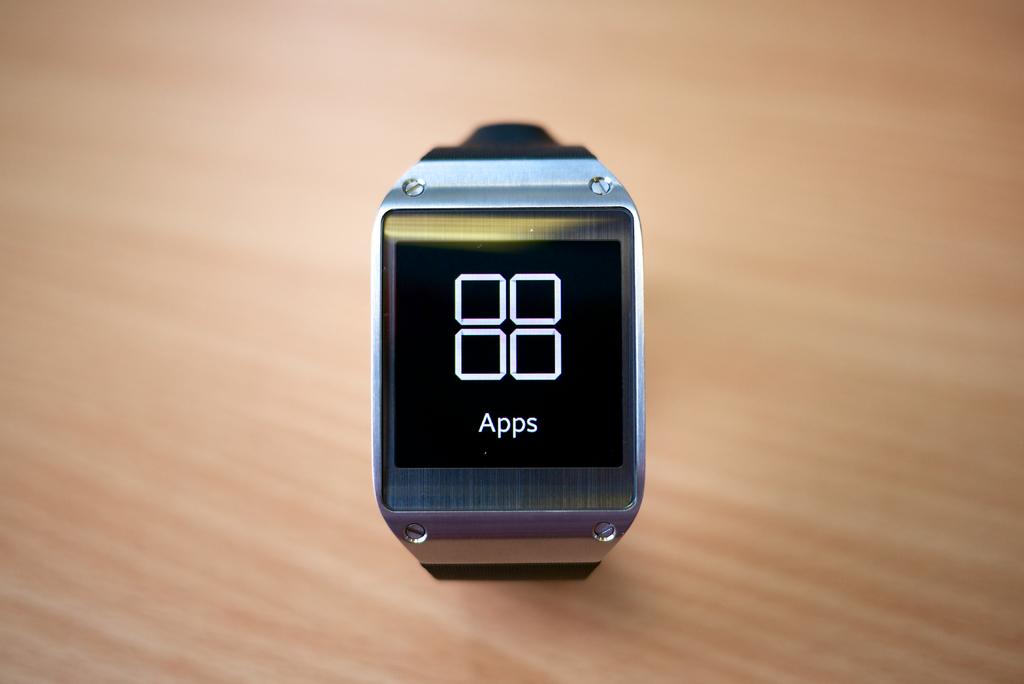What word is on the watch?
Your answer should be compact. Apps. 